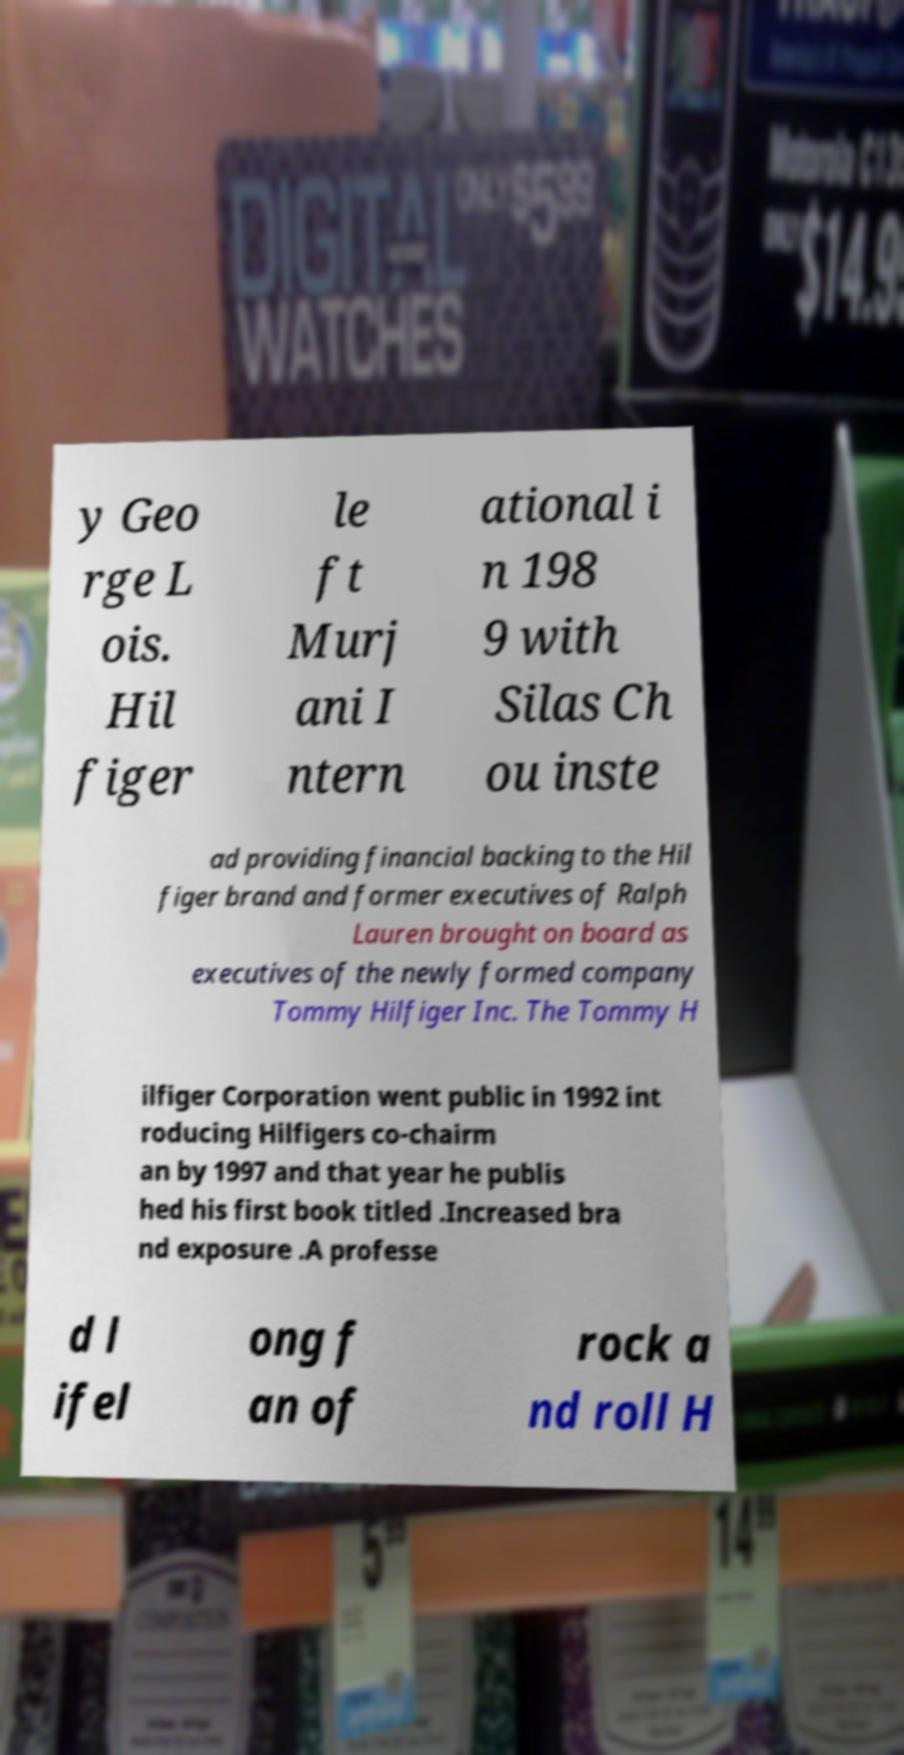What messages or text are displayed in this image? I need them in a readable, typed format. y Geo rge L ois. Hil figer le ft Murj ani I ntern ational i n 198 9 with Silas Ch ou inste ad providing financial backing to the Hil figer brand and former executives of Ralph Lauren brought on board as executives of the newly formed company Tommy Hilfiger Inc. The Tommy H ilfiger Corporation went public in 1992 int roducing Hilfigers co-chairm an by 1997 and that year he publis hed his first book titled .Increased bra nd exposure .A professe d l ifel ong f an of rock a nd roll H 